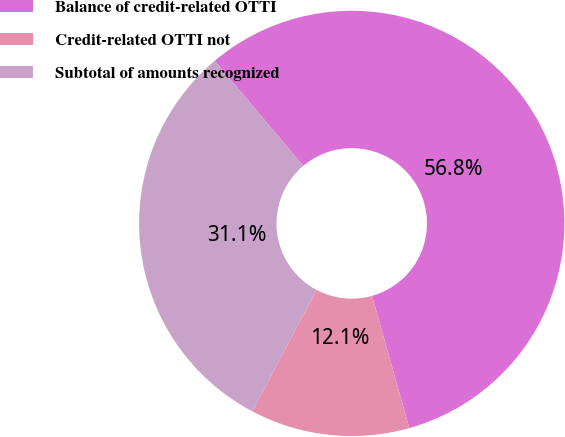Convert chart to OTSL. <chart><loc_0><loc_0><loc_500><loc_500><pie_chart><fcel>Balance of credit-related OTTI<fcel>Credit-related OTTI not<fcel>Subtotal of amounts recognized<nl><fcel>56.78%<fcel>12.11%<fcel>31.11%<nl></chart> 